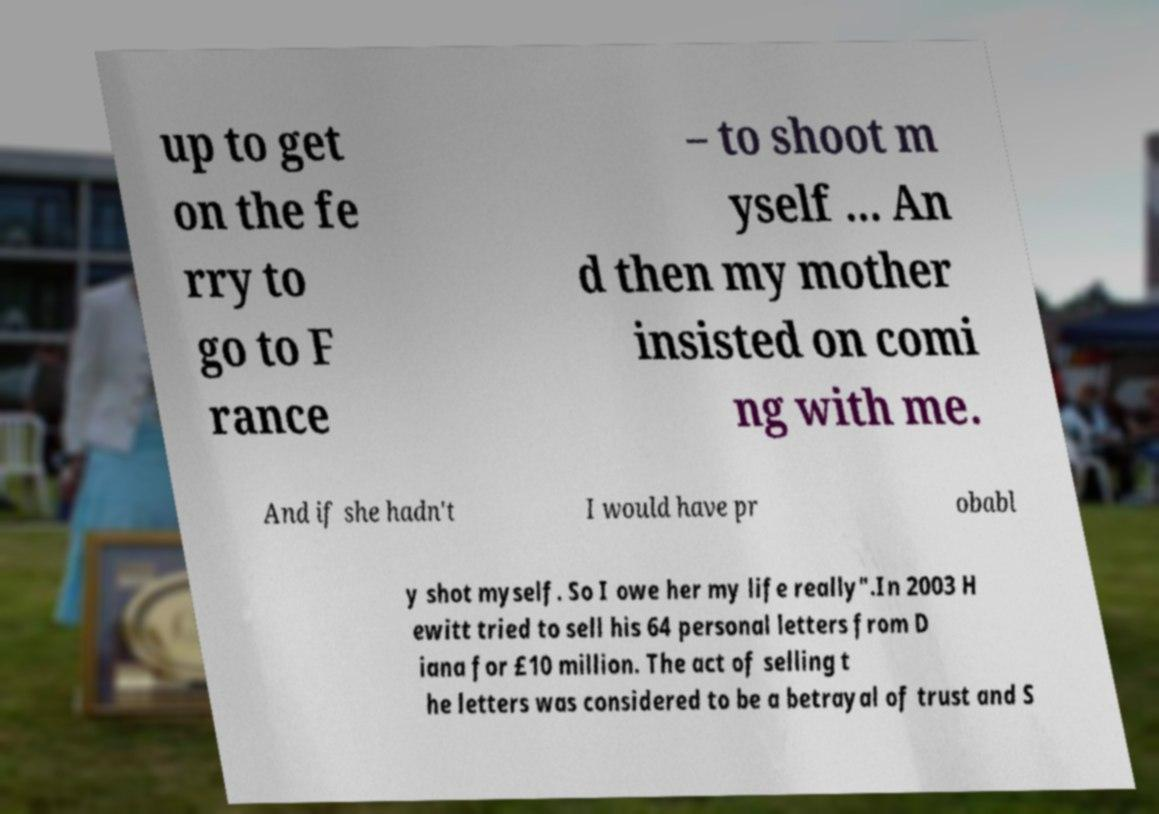There's text embedded in this image that I need extracted. Can you transcribe it verbatim? up to get on the fe rry to go to F rance – to shoot m yself ... An d then my mother insisted on comi ng with me. And if she hadn't I would have pr obabl y shot myself. So I owe her my life really".In 2003 H ewitt tried to sell his 64 personal letters from D iana for £10 million. The act of selling t he letters was considered to be a betrayal of trust and S 